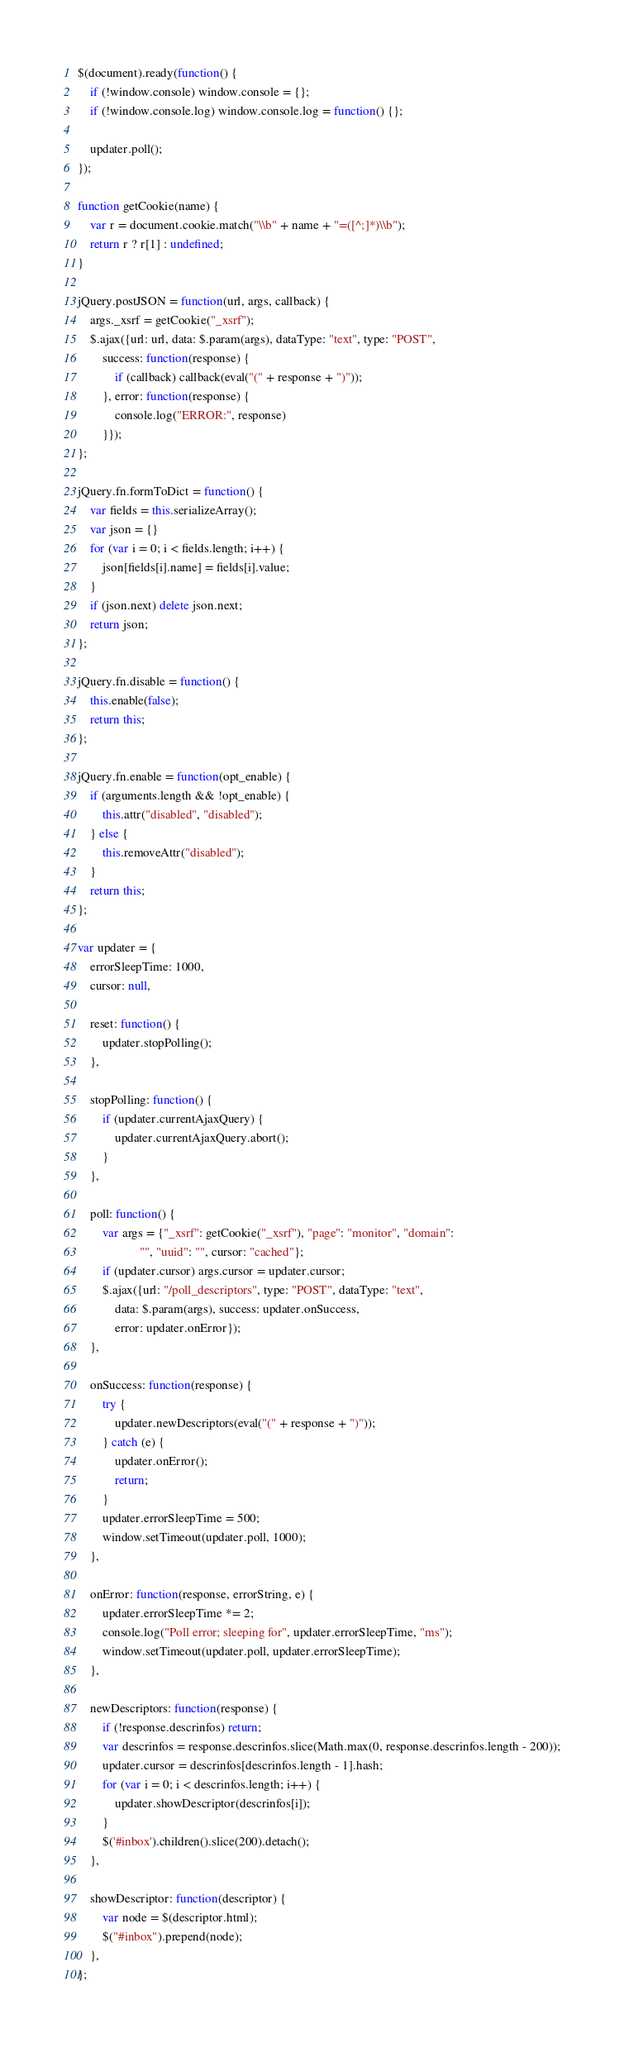<code> <loc_0><loc_0><loc_500><loc_500><_JavaScript_>
$(document).ready(function() {
    if (!window.console) window.console = {};
    if (!window.console.log) window.console.log = function() {};

    updater.poll();
});

function getCookie(name) {
    var r = document.cookie.match("\\b" + name + "=([^;]*)\\b");
    return r ? r[1] : undefined;
}

jQuery.postJSON = function(url, args, callback) {
    args._xsrf = getCookie("_xsrf");
    $.ajax({url: url, data: $.param(args), dataType: "text", type: "POST",
        success: function(response) {
            if (callback) callback(eval("(" + response + ")"));
        }, error: function(response) {
            console.log("ERROR:", response)
        }});
};

jQuery.fn.formToDict = function() {
    var fields = this.serializeArray();
    var json = {}
    for (var i = 0; i < fields.length; i++) {
        json[fields[i].name] = fields[i].value;
    }
    if (json.next) delete json.next;
    return json;
};

jQuery.fn.disable = function() {
    this.enable(false);
    return this;
};

jQuery.fn.enable = function(opt_enable) {
    if (arguments.length && !opt_enable) {
        this.attr("disabled", "disabled");
    } else {
        this.removeAttr("disabled");
    }
    return this;
};

var updater = {
    errorSleepTime: 1000,
    cursor: null,

    reset: function() {
        updater.stopPolling();
    },

    stopPolling: function() {
        if (updater.currentAjaxQuery) {
            updater.currentAjaxQuery.abort();
        }
    },

    poll: function() {
        var args = {"_xsrf": getCookie("_xsrf"), "page": "monitor", "domain":
                    "", "uuid": "", cursor: "cached"};
        if (updater.cursor) args.cursor = updater.cursor;
        $.ajax({url: "/poll_descriptors", type: "POST", dataType: "text",
            data: $.param(args), success: updater.onSuccess,
            error: updater.onError});
    },

    onSuccess: function(response) {
        try {
            updater.newDescriptors(eval("(" + response + ")"));
        } catch (e) {
            updater.onError();
            return;
        }
        updater.errorSleepTime = 500;
        window.setTimeout(updater.poll, 1000);
    },

    onError: function(response, errorString, e) {
        updater.errorSleepTime *= 2;
        console.log("Poll error; sleeping for", updater.errorSleepTime, "ms");
        window.setTimeout(updater.poll, updater.errorSleepTime);
    },

    newDescriptors: function(response) {
        if (!response.descrinfos) return;
        var descrinfos = response.descrinfos.slice(Math.max(0, response.descrinfos.length - 200));
        updater.cursor = descrinfos[descrinfos.length - 1].hash;
        for (var i = 0; i < descrinfos.length; i++) {
            updater.showDescriptor(descrinfos[i]);
        }
        $('#inbox').children().slice(200).detach();
    },

    showDescriptor: function(descriptor) {
        var node = $(descriptor.html);
        $("#inbox").prepend(node);
    },
};
</code> 